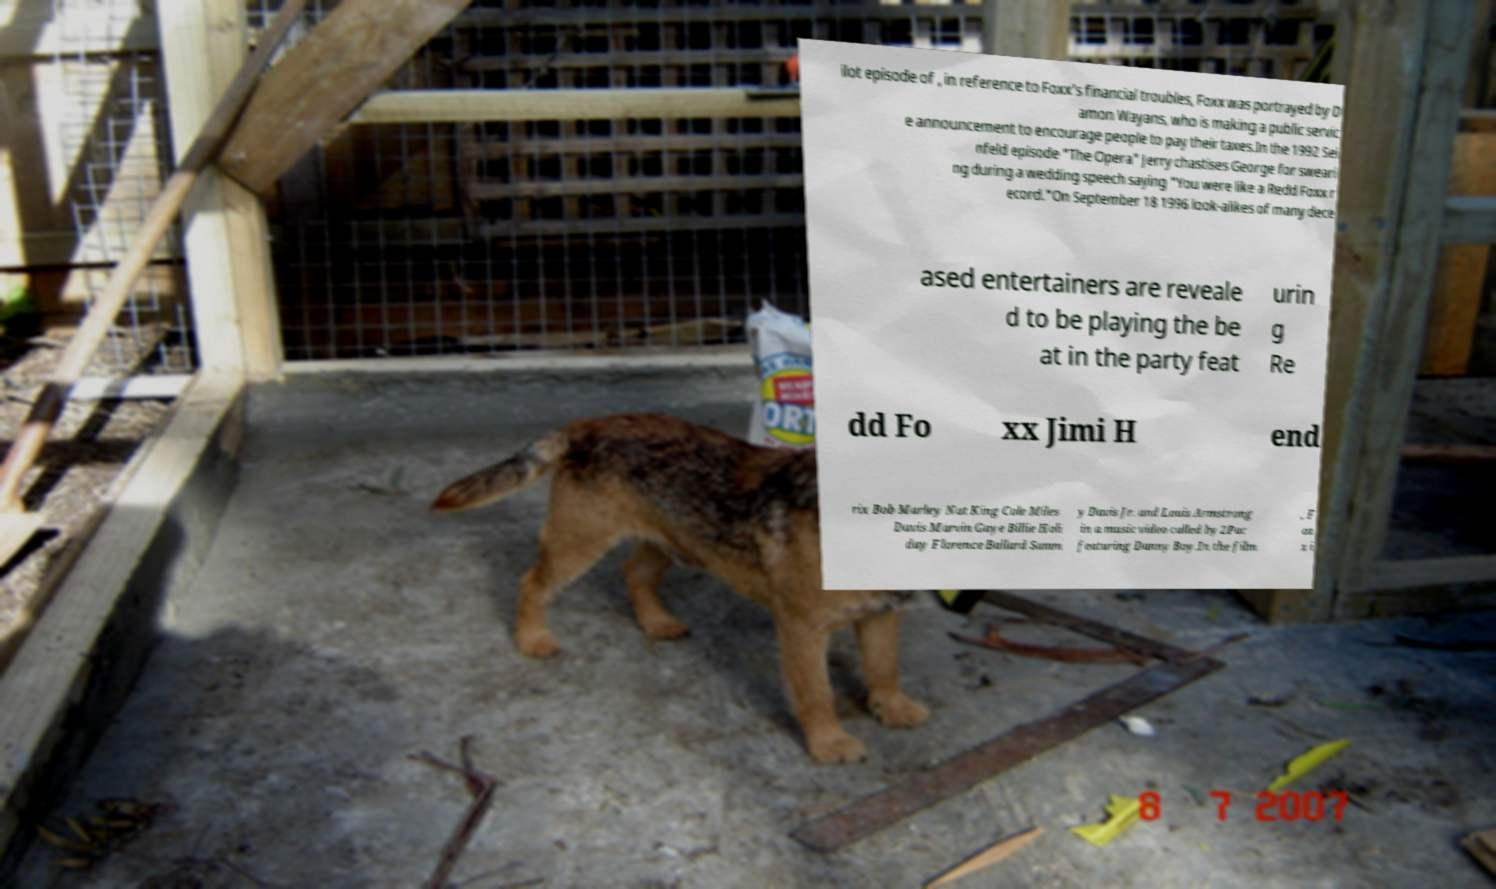Can you read and provide the text displayed in the image?This photo seems to have some interesting text. Can you extract and type it out for me? ilot episode of , in reference to Foxx's financial troubles, Foxx was portrayed by D amon Wayans, who is making a public servic e announcement to encourage people to pay their taxes.In the 1992 Sei nfeld episode "The Opera" Jerry chastises George for sweari ng during a wedding speech saying "You were like a Redd Foxx r ecord."On September 18 1996 look-alikes of many dece ased entertainers are reveale d to be playing the be at in the party feat urin g Re dd Fo xx Jimi H end rix Bob Marley Nat King Cole Miles Davis Marvin Gaye Billie Holi day Florence Ballard Samm y Davis Jr. and Louis Armstrong in a music video called by 2Pac featuring Danny Boy.In the film , F ox x i 